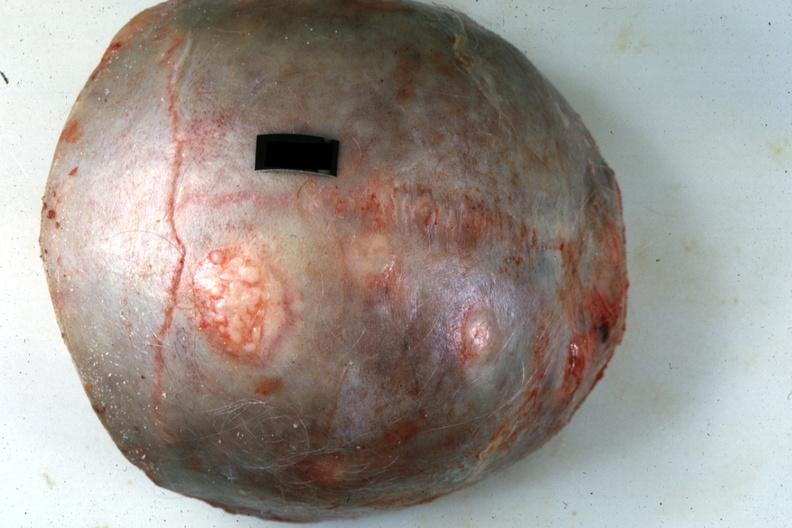what is present?
Answer the question using a single word or phrase. Bone, calvarium 